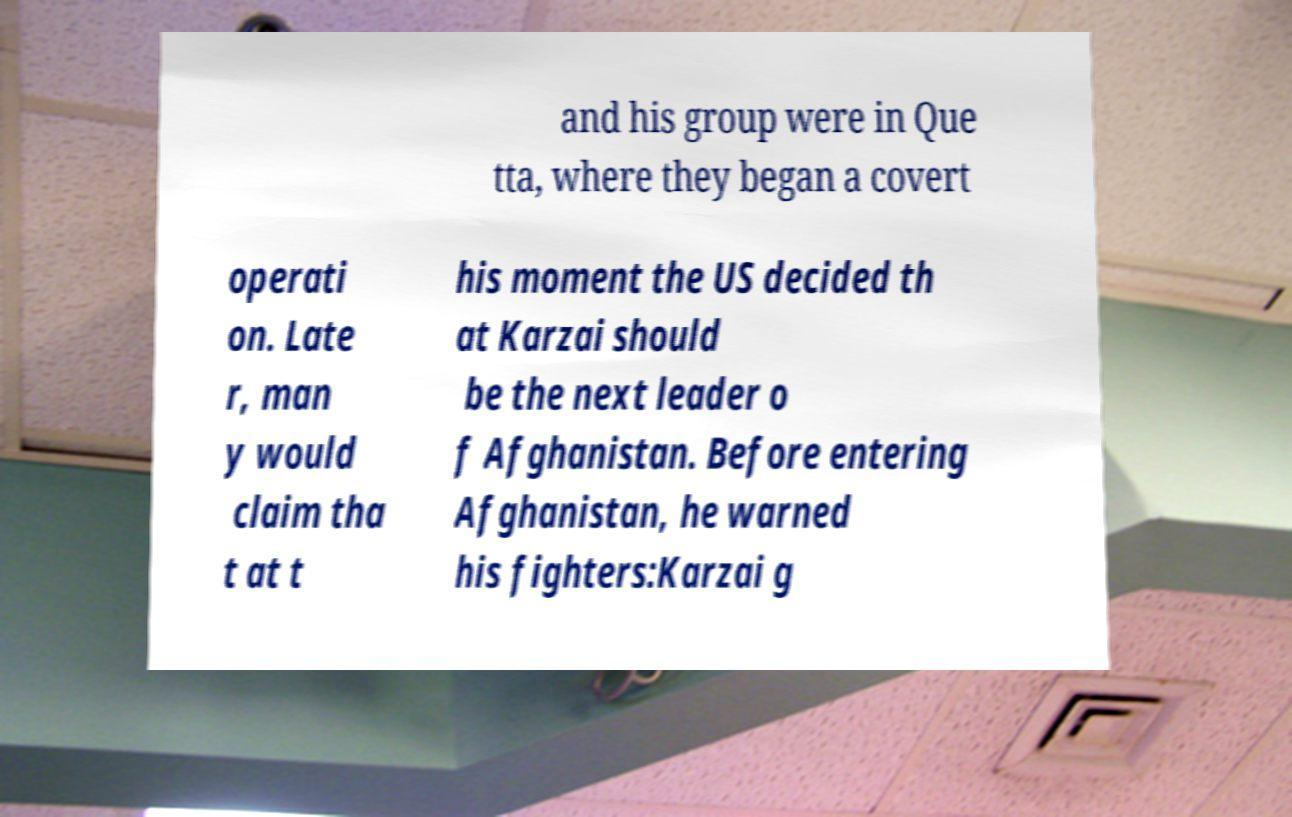What messages or text are displayed in this image? I need them in a readable, typed format. and his group were in Que tta, where they began a covert operati on. Late r, man y would claim tha t at t his moment the US decided th at Karzai should be the next leader o f Afghanistan. Before entering Afghanistan, he warned his fighters:Karzai g 